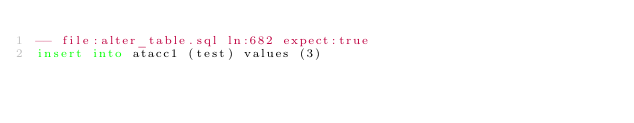<code> <loc_0><loc_0><loc_500><loc_500><_SQL_>-- file:alter_table.sql ln:682 expect:true
insert into atacc1 (test) values (3)
</code> 